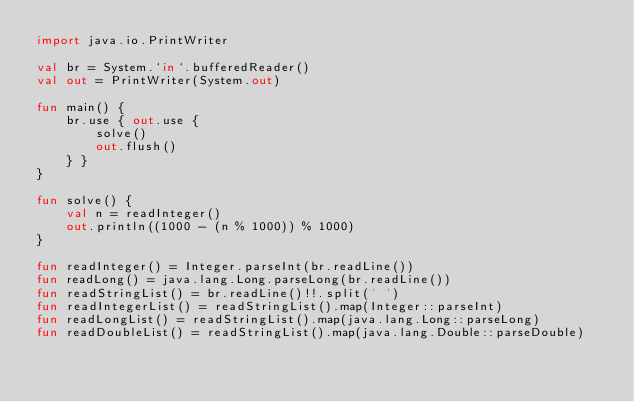Convert code to text. <code><loc_0><loc_0><loc_500><loc_500><_Kotlin_>import java.io.PrintWriter

val br = System.`in`.bufferedReader()
val out = PrintWriter(System.out)

fun main() {
    br.use { out.use {
        solve()
        out.flush()
    } }
}

fun solve() {
    val n = readInteger()
    out.println((1000 - (n % 1000)) % 1000)
}

fun readInteger() = Integer.parseInt(br.readLine())
fun readLong() = java.lang.Long.parseLong(br.readLine())
fun readStringList() = br.readLine()!!.split(' ')
fun readIntegerList() = readStringList().map(Integer::parseInt)
fun readLongList() = readStringList().map(java.lang.Long::parseLong)
fun readDoubleList() = readStringList().map(java.lang.Double::parseDouble)
</code> 